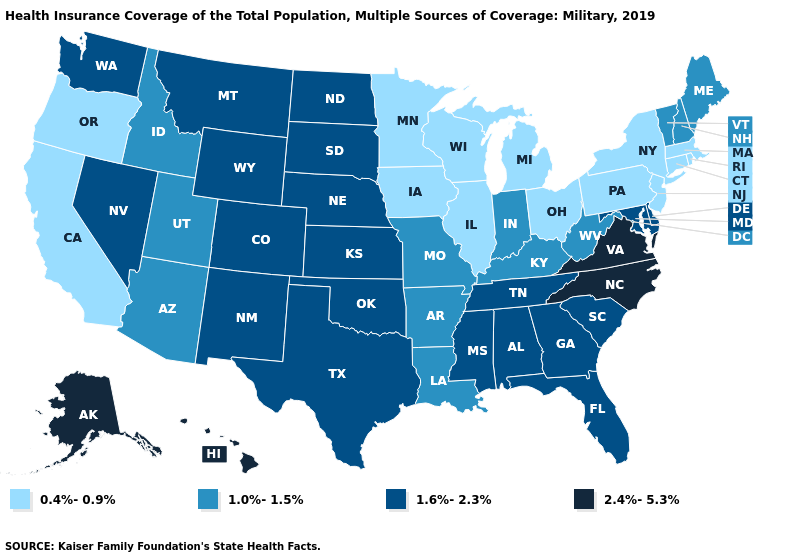What is the value of Kansas?
Concise answer only. 1.6%-2.3%. What is the value of Minnesota?
Be succinct. 0.4%-0.9%. Name the states that have a value in the range 1.0%-1.5%?
Write a very short answer. Arizona, Arkansas, Idaho, Indiana, Kentucky, Louisiana, Maine, Missouri, New Hampshire, Utah, Vermont, West Virginia. Name the states that have a value in the range 1.0%-1.5%?
Short answer required. Arizona, Arkansas, Idaho, Indiana, Kentucky, Louisiana, Maine, Missouri, New Hampshire, Utah, Vermont, West Virginia. Does Iowa have the lowest value in the USA?
Be succinct. Yes. How many symbols are there in the legend?
Write a very short answer. 4. Which states have the lowest value in the USA?
Keep it brief. California, Connecticut, Illinois, Iowa, Massachusetts, Michigan, Minnesota, New Jersey, New York, Ohio, Oregon, Pennsylvania, Rhode Island, Wisconsin. What is the value of South Carolina?
Give a very brief answer. 1.6%-2.3%. How many symbols are there in the legend?
Short answer required. 4. Does Mississippi have the highest value in the USA?
Short answer required. No. Does Hawaii have the highest value in the USA?
Short answer required. Yes. Does Delaware have the lowest value in the USA?
Quick response, please. No. Does Maryland have the highest value in the USA?
Answer briefly. No. What is the value of Mississippi?
Write a very short answer. 1.6%-2.3%. 